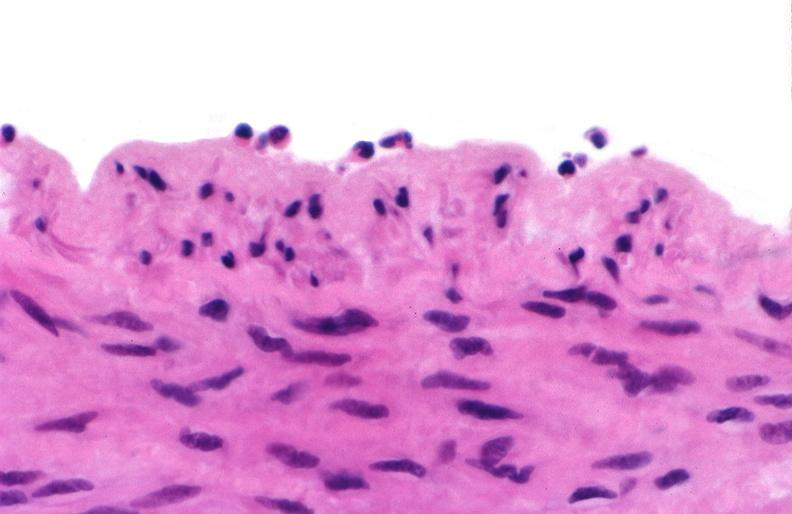does this image show acute inflammation, rolling leukocytes polymorphonuclear neutrophils?
Answer the question using a single word or phrase. Yes 